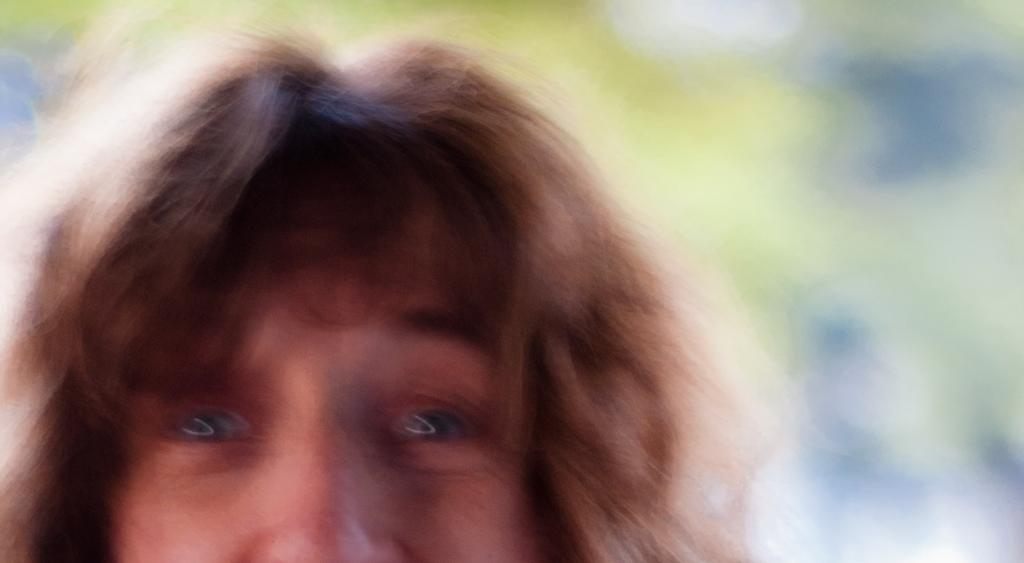What is the main subject of the image? There is a person in the image. What part of the person's body is visible? The person's head is visible in the image. Can you describe the background of the image? There are blurred objects behind the person. How many attempts did the person make to break the vase in the image? There is no vase present in the image, so it is not possible to determine how many attempts the person made to break it. 